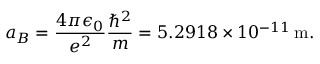Convert formula to latex. <formula><loc_0><loc_0><loc_500><loc_500>a _ { B } = \frac { 4 \pi \epsilon _ { 0 } } { e ^ { 2 } } \frac { \hbar { ^ } { 2 } } { m } = 5 . 2 9 1 8 \times 1 0 ^ { - 1 1 } \, m .</formula> 